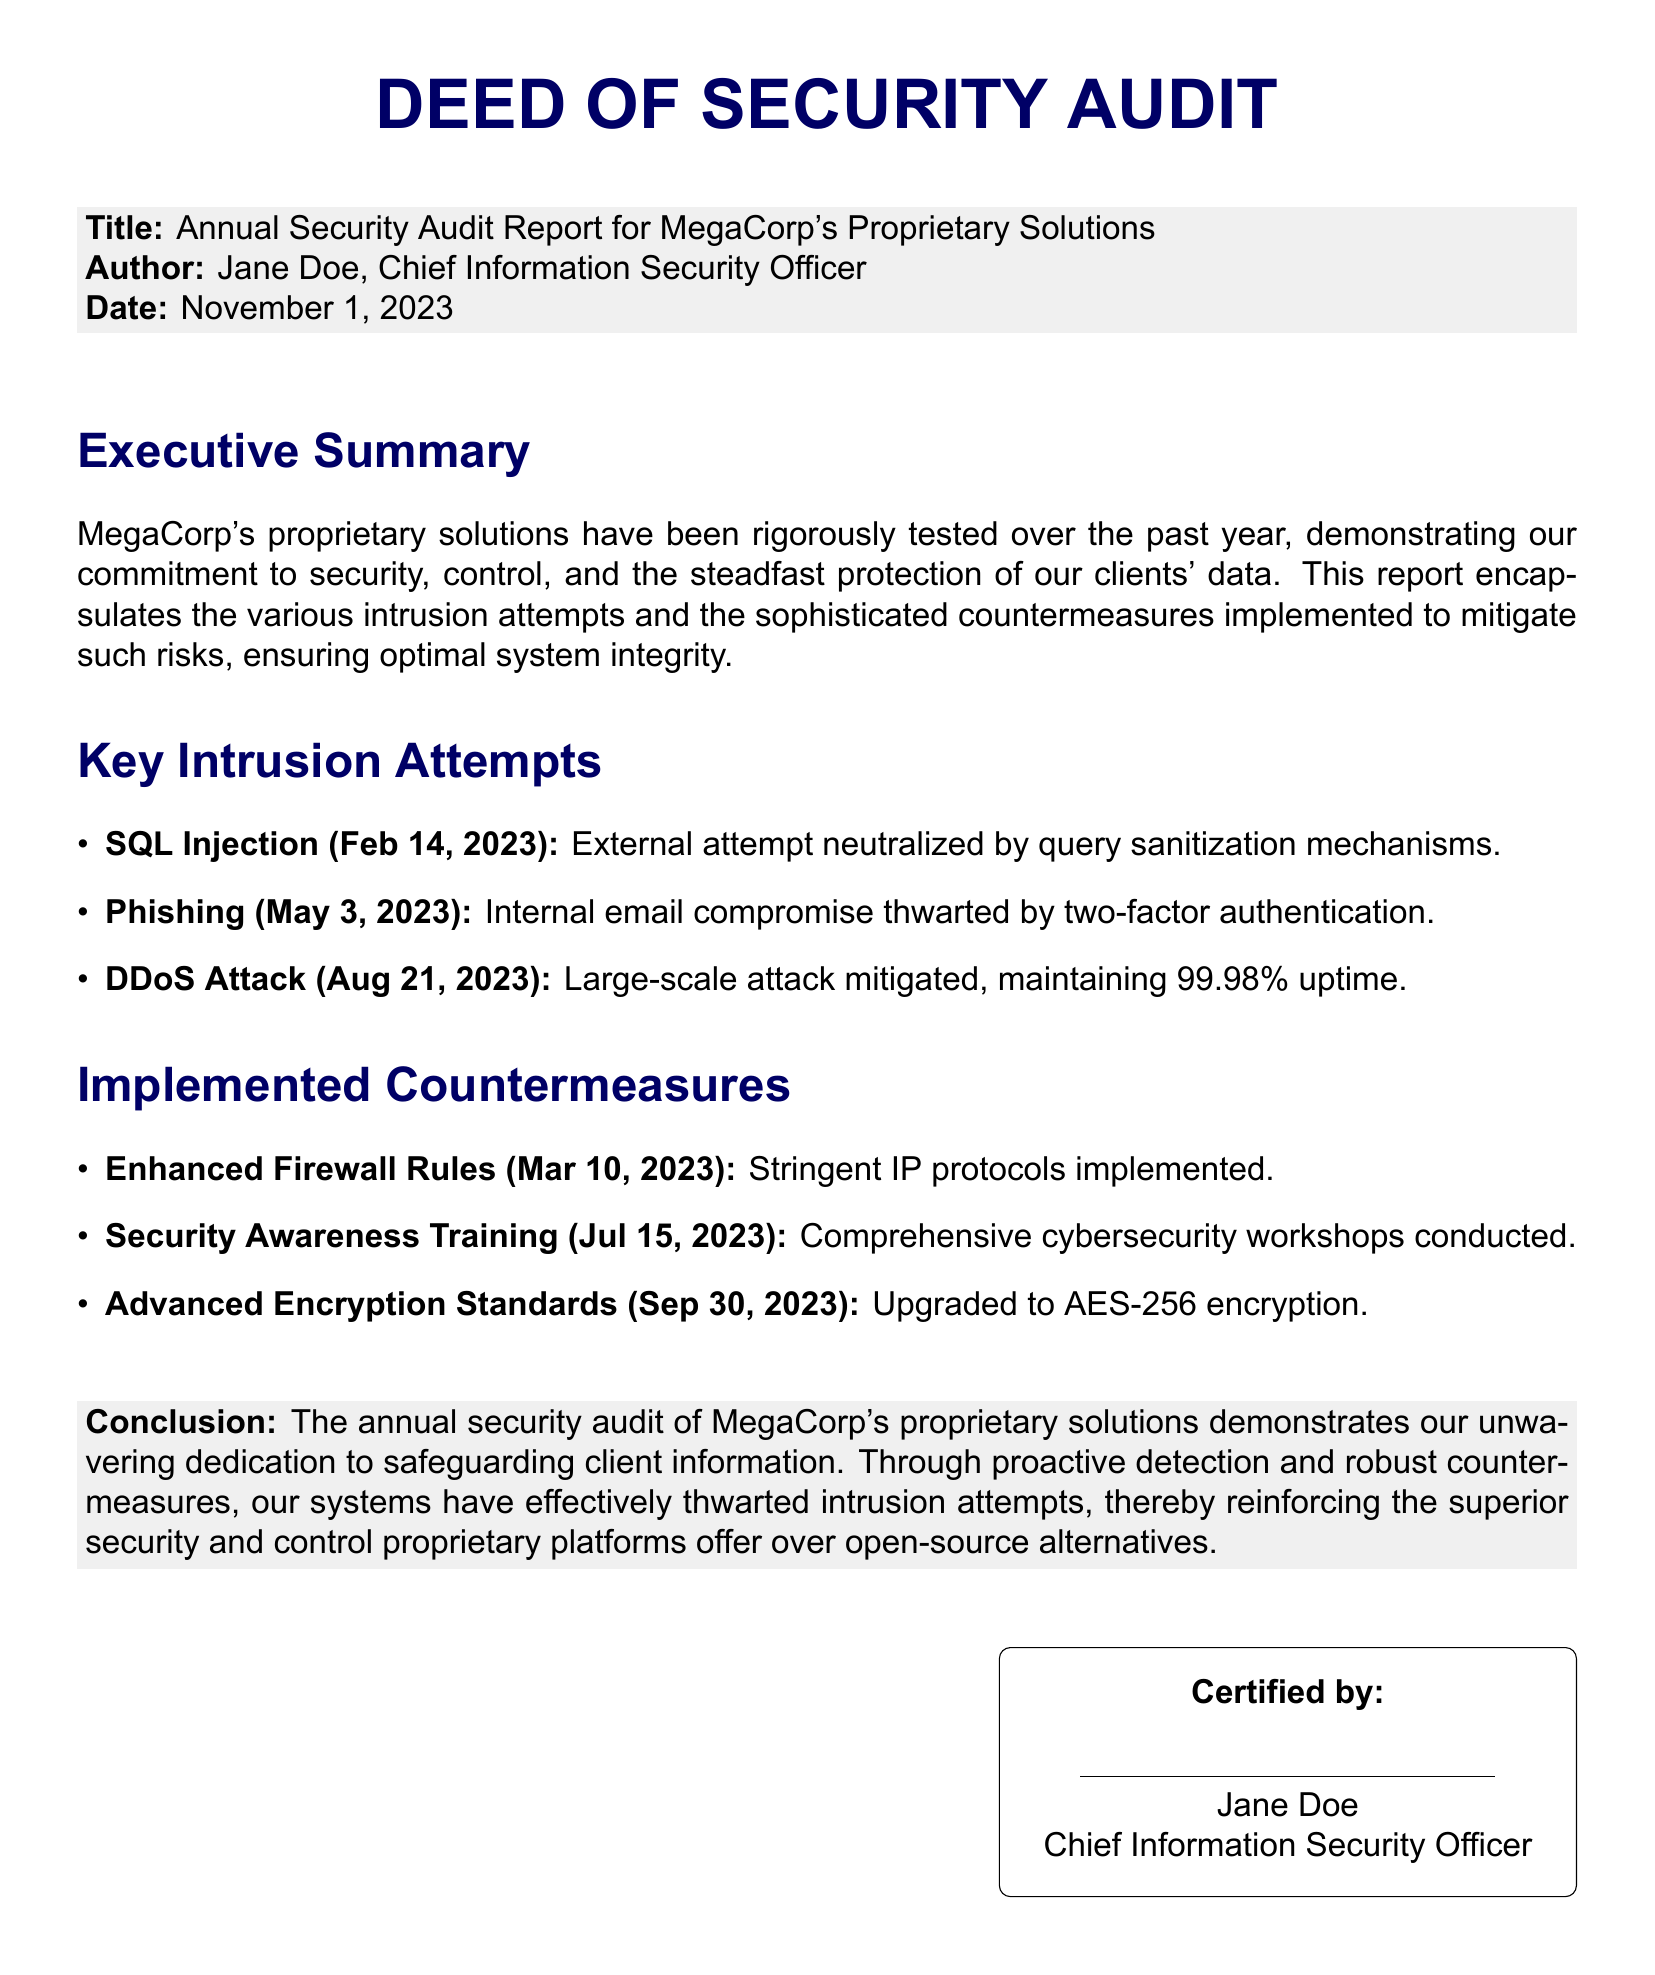What is the title of the report? The title can be found in the document's header, which is "Annual Security Audit Report for MegaCorp's Proprietary Solutions."
Answer: Annual Security Audit Report for MegaCorp's Proprietary Solutions Who is the author of the report? The author is mentioned in the document as the Chief Information Security Officer.
Answer: Jane Doe What was the date of the audit report? The date appears in the introductory section of the document.
Answer: November 1, 2023 How many key intrusion attempts are listed in the document? The number of intrusion attempts is indicated by counting the items in the "Key Intrusion Attempts" section.
Answer: Three What percentage of uptime was maintained during the DDoS attack? The uptime percentage is specified in the DDoS attack entry of the report.
Answer: 99.98% What encryption standard was upgraded to in the report? The document mentions the encryption standard in the "Implemented Countermeasures" section.
Answer: AES-256 What training was conducted on July 15, 2023? The specific type of training is detailed in the "Implemented Countermeasures" section.
Answer: Security Awareness Training What does the conclusion emphasize about proprietary solutions? The conclusion summarizes the main point about proprietary solutions in terms of security.
Answer: Superior security and control 